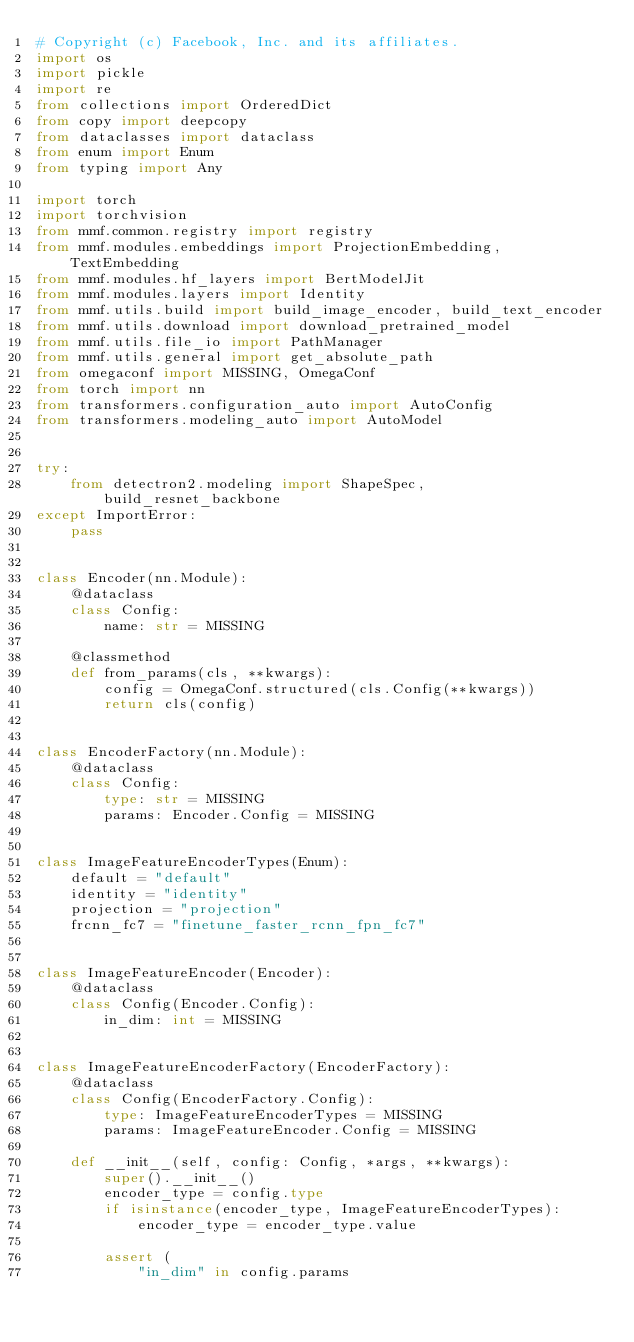Convert code to text. <code><loc_0><loc_0><loc_500><loc_500><_Python_># Copyright (c) Facebook, Inc. and its affiliates.
import os
import pickle
import re
from collections import OrderedDict
from copy import deepcopy
from dataclasses import dataclass
from enum import Enum
from typing import Any

import torch
import torchvision
from mmf.common.registry import registry
from mmf.modules.embeddings import ProjectionEmbedding, TextEmbedding
from mmf.modules.hf_layers import BertModelJit
from mmf.modules.layers import Identity
from mmf.utils.build import build_image_encoder, build_text_encoder
from mmf.utils.download import download_pretrained_model
from mmf.utils.file_io import PathManager
from mmf.utils.general import get_absolute_path
from omegaconf import MISSING, OmegaConf
from torch import nn
from transformers.configuration_auto import AutoConfig
from transformers.modeling_auto import AutoModel


try:
    from detectron2.modeling import ShapeSpec, build_resnet_backbone
except ImportError:
    pass


class Encoder(nn.Module):
    @dataclass
    class Config:
        name: str = MISSING

    @classmethod
    def from_params(cls, **kwargs):
        config = OmegaConf.structured(cls.Config(**kwargs))
        return cls(config)


class EncoderFactory(nn.Module):
    @dataclass
    class Config:
        type: str = MISSING
        params: Encoder.Config = MISSING


class ImageFeatureEncoderTypes(Enum):
    default = "default"
    identity = "identity"
    projection = "projection"
    frcnn_fc7 = "finetune_faster_rcnn_fpn_fc7"


class ImageFeatureEncoder(Encoder):
    @dataclass
    class Config(Encoder.Config):
        in_dim: int = MISSING


class ImageFeatureEncoderFactory(EncoderFactory):
    @dataclass
    class Config(EncoderFactory.Config):
        type: ImageFeatureEncoderTypes = MISSING
        params: ImageFeatureEncoder.Config = MISSING

    def __init__(self, config: Config, *args, **kwargs):
        super().__init__()
        encoder_type = config.type
        if isinstance(encoder_type, ImageFeatureEncoderTypes):
            encoder_type = encoder_type.value

        assert (
            "in_dim" in config.params</code> 